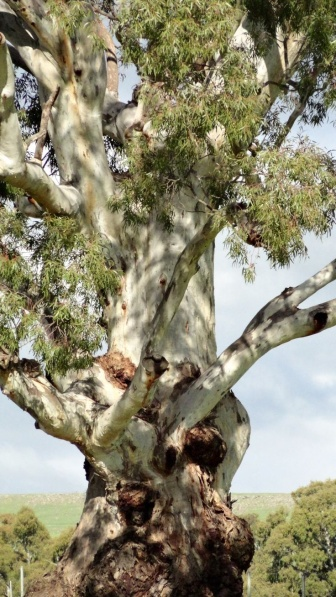Can you elaborate on the elements of the picture provided? The picture displays an impressive eucalyptus tree, identifiable by its distinctive smooth, flaking bark and the leathery texture of its leaves. This majestic specimen stands tall, its thick, sinewy trunk branching out into an expansive network of limbs. The tree's notable features include several large burls or galls, which are growths that suggest past injury or stress but also a testament to the tree's resilience. The branches stretch outwards, clothed in a vibrant plumage of leaves that hint at a robust and mature life. The foliage's green hue offers a refreshing contrast to the subtle shades of brown and gray on the bark, indicative of the tree's evergreen nature. Situated in a grassy field, the tree's imposing form is further accentuated by the open, clear blue sky above, with no visual interruptions from man-made structures or power lines, pointing to a remote or preserved natural setting. This solitary giant underscores the power and tranquility of the natural world and could possibly serve as a landmark or a testament to the native flora of its region. 